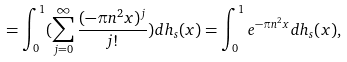Convert formula to latex. <formula><loc_0><loc_0><loc_500><loc_500>= \int _ { 0 } ^ { 1 } ( \sum _ { j = 0 } ^ { \infty } \frac { ( - \pi n ^ { 2 } x ) ^ { j } } { j ! } ) d h _ { s } ( x ) = \int _ { 0 } ^ { 1 } e ^ { - \pi n ^ { 2 } x } d h _ { s } ( x ) ,</formula> 